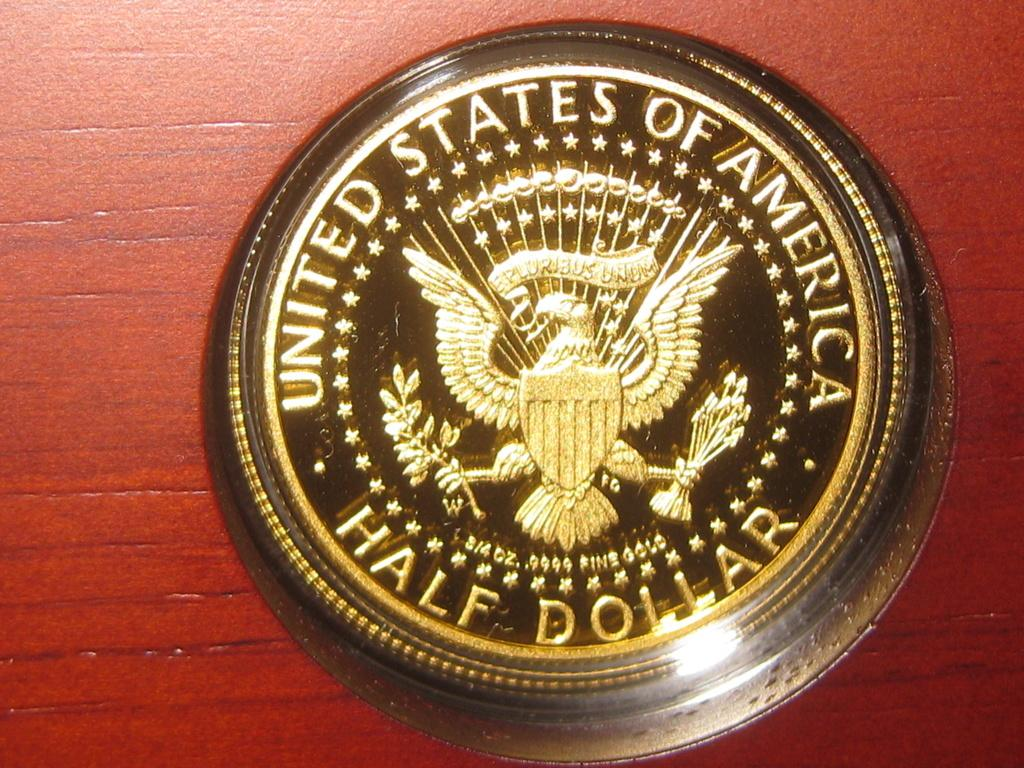Provide a one-sentence caption for the provided image. A United States Half Dollar is sitting on a wooden surface. 